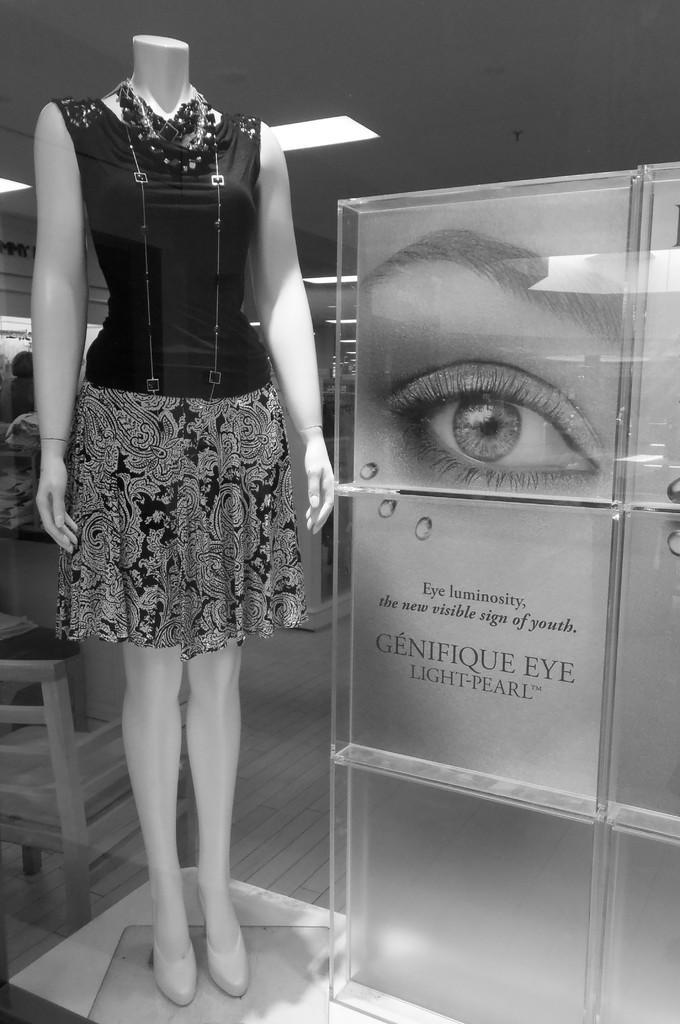Can you describe this image briefly? In this image we can see a mannequin with the dress and also a neck piece. We can also see a board with the text. We can see the ceiling with the lights. We can also see the chair and also the floor. 